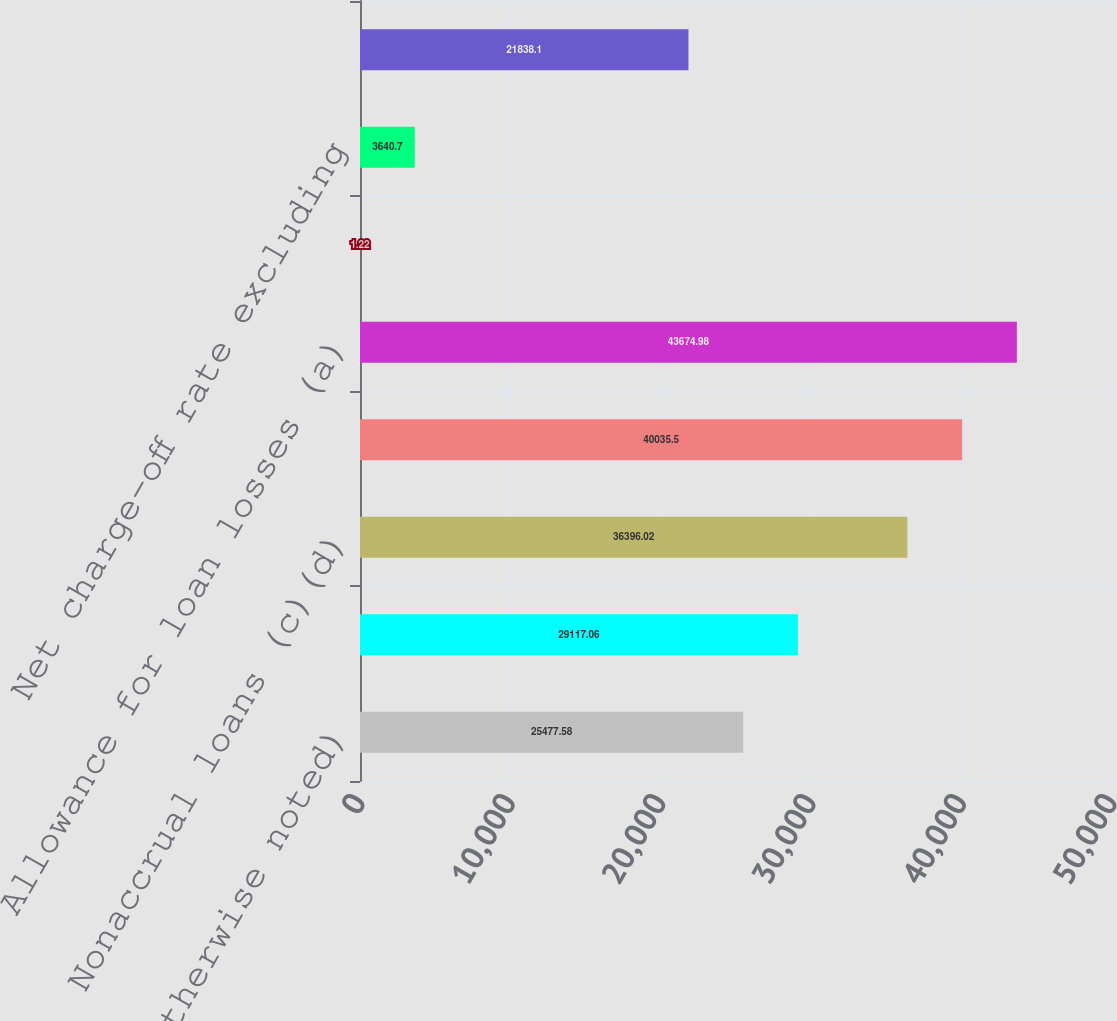Convert chart to OTSL. <chart><loc_0><loc_0><loc_500><loc_500><bar_chart><fcel>where otherwise noted)<fcel>Net charge-offs (a)(b)<fcel>Nonaccrual loans (c)(d)<fcel>Nonperforming assets (c)(d)(e)<fcel>Allowance for loan losses (a)<fcel>Net charge-off rate (a)(b)<fcel>Net charge-off rate excluding<fcel>Allowance for loan losses to<nl><fcel>25477.6<fcel>29117.1<fcel>36396<fcel>40035.5<fcel>43675<fcel>1.22<fcel>3640.7<fcel>21838.1<nl></chart> 